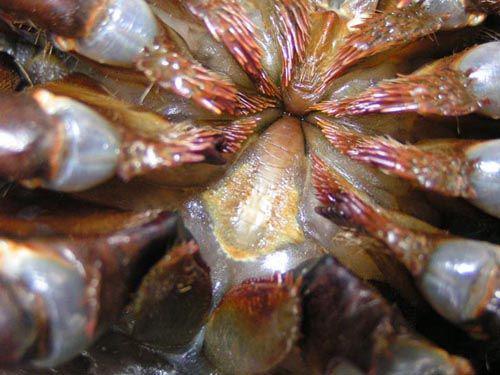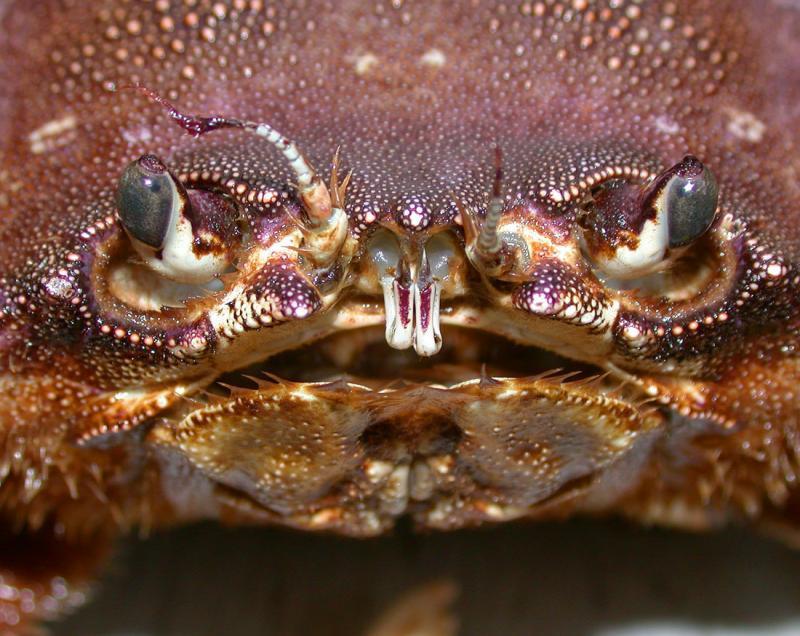The first image is the image on the left, the second image is the image on the right. For the images shown, is this caption "One image shows the underside of a crab, and the other image shows a face-forward crab with eyes visible." true? Answer yes or no. Yes. The first image is the image on the left, the second image is the image on the right. Assess this claim about the two images: "In one of the images, the underbelly of a crab is shown.". Correct or not? Answer yes or no. Yes. 